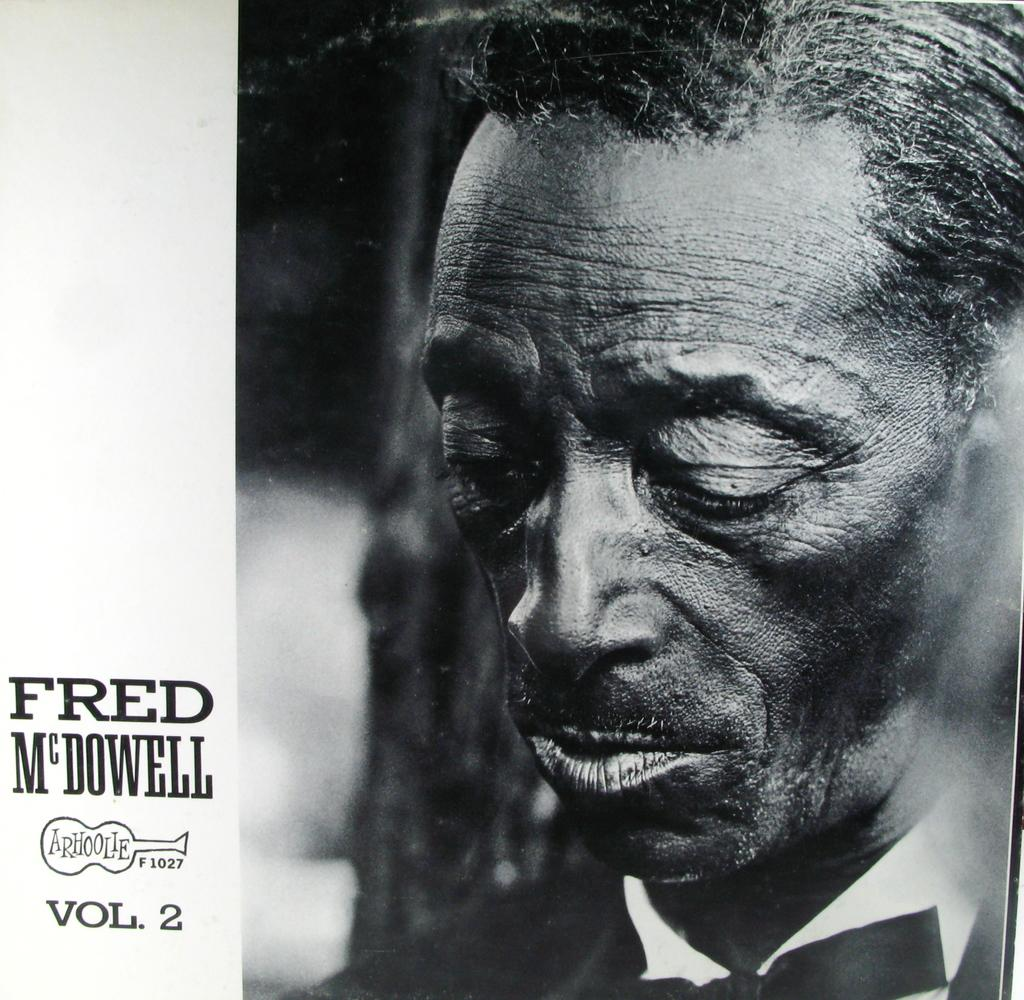What is the focus of the image? The image is zoomed in, so the focus is on a specific area or subject. Can you describe the person on the right side of the image? Unfortunately, the image is zoomed in and the person is not clearly visible. What can be seen in the background of the image? The background of the image is blurry, so it is difficult to make out any specific details. What is present on the left side of the image? There is text and numbers on the left side of the image. What is the person on the right side of the image feeling? There is no way to determine the person's emotions from the image, as their facial expression is not visible. How many stars can be seen in the image? There are no stars present in the image. 